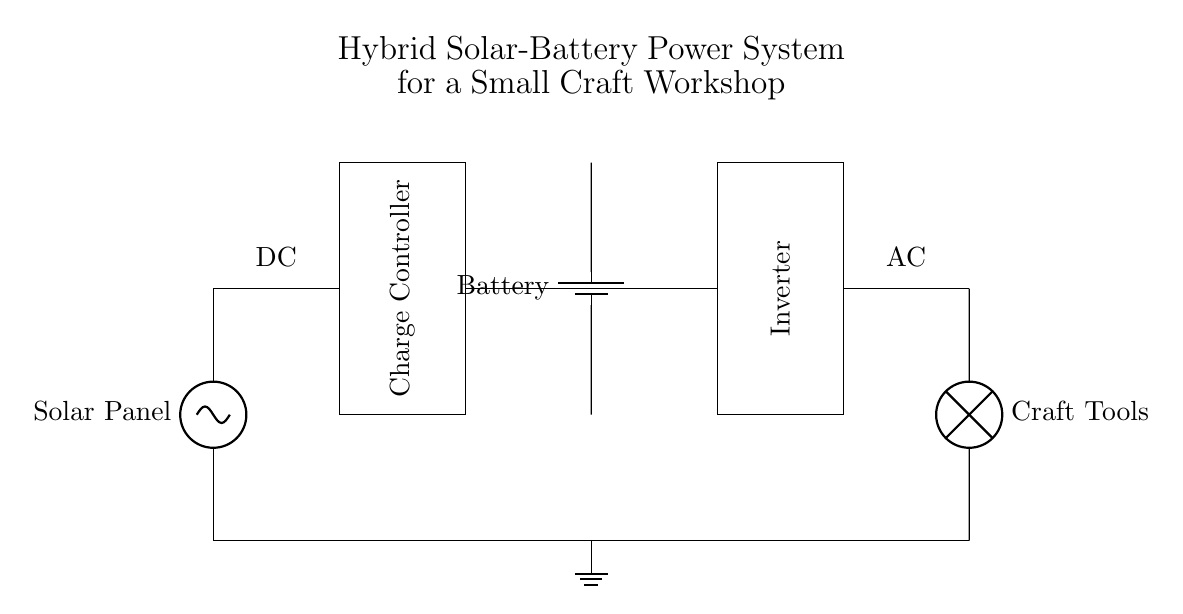What components are present in the circuit? The circuit contains a solar panel, charge controller, battery, inverter, and AC load labeled as craft tools.
Answer: solar panel, charge controller, battery, inverter, craft tools What is the purpose of the charge controller in the circuit? The charge controller regulates the voltage and current coming from the solar panel to prevent overcharging the battery.
Answer: regulate voltage and current What type of load is powered by this system? The AC load is described as craft tools, indicating that it is an alternating current appliance used for crafting.
Answer: craft tools What is the function of the inverter in this circuit? The inverter converts the direct current from the battery to alternating current, suitable for powering the AC load.
Answer: convert DC to AC How are the solar panel and battery connected in this circuit? The solar panel is connected to the charge controller, which then connects to the battery, forming a pathway for energy storage.
Answer: connected through charge controller What type of energy does the battery store in this system? The battery stores electrical energy generated from the solar panel in the form of direct current.
Answer: electrical energy (DC) What is the primary benefit of using this hybrid system? The hybrid system allows for the utilization of solar energy while providing backup storage from the battery, ensuring a continuous power supply.
Answer: continuous power supply 